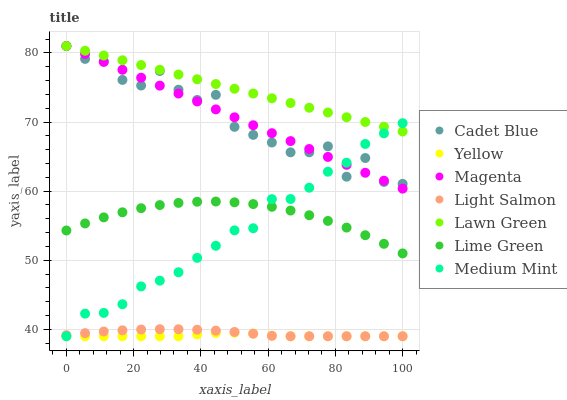Does Yellow have the minimum area under the curve?
Answer yes or no. Yes. Does Lawn Green have the maximum area under the curve?
Answer yes or no. Yes. Does Light Salmon have the minimum area under the curve?
Answer yes or no. No. Does Light Salmon have the maximum area under the curve?
Answer yes or no. No. Is Lawn Green the smoothest?
Answer yes or no. Yes. Is Cadet Blue the roughest?
Answer yes or no. Yes. Is Light Salmon the smoothest?
Answer yes or no. No. Is Light Salmon the roughest?
Answer yes or no. No. Does Medium Mint have the lowest value?
Answer yes or no. Yes. Does Lawn Green have the lowest value?
Answer yes or no. No. Does Magenta have the highest value?
Answer yes or no. Yes. Does Light Salmon have the highest value?
Answer yes or no. No. Is Yellow less than Lawn Green?
Answer yes or no. Yes. Is Cadet Blue greater than Yellow?
Answer yes or no. Yes. Does Medium Mint intersect Magenta?
Answer yes or no. Yes. Is Medium Mint less than Magenta?
Answer yes or no. No. Is Medium Mint greater than Magenta?
Answer yes or no. No. Does Yellow intersect Lawn Green?
Answer yes or no. No. 